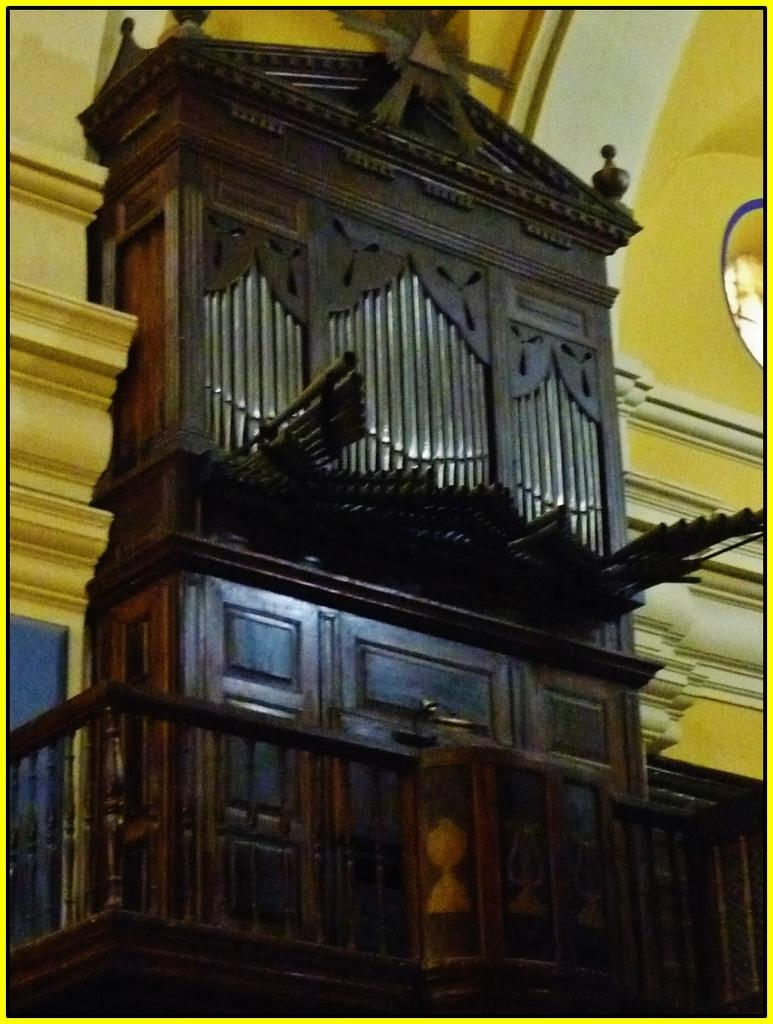What type of furniture is present in the image? There is a wooden cabinet in the image. What is located behind the wooden cabinet? There is a wall behind the wooden cabinet. What type of hat is the moon wearing in the image? There is no moon or hat present in the image. What type of exchange is taking place between the wooden cabinet and the wall? There is no exchange taking place between the wooden cabinet and the wall in the image. 